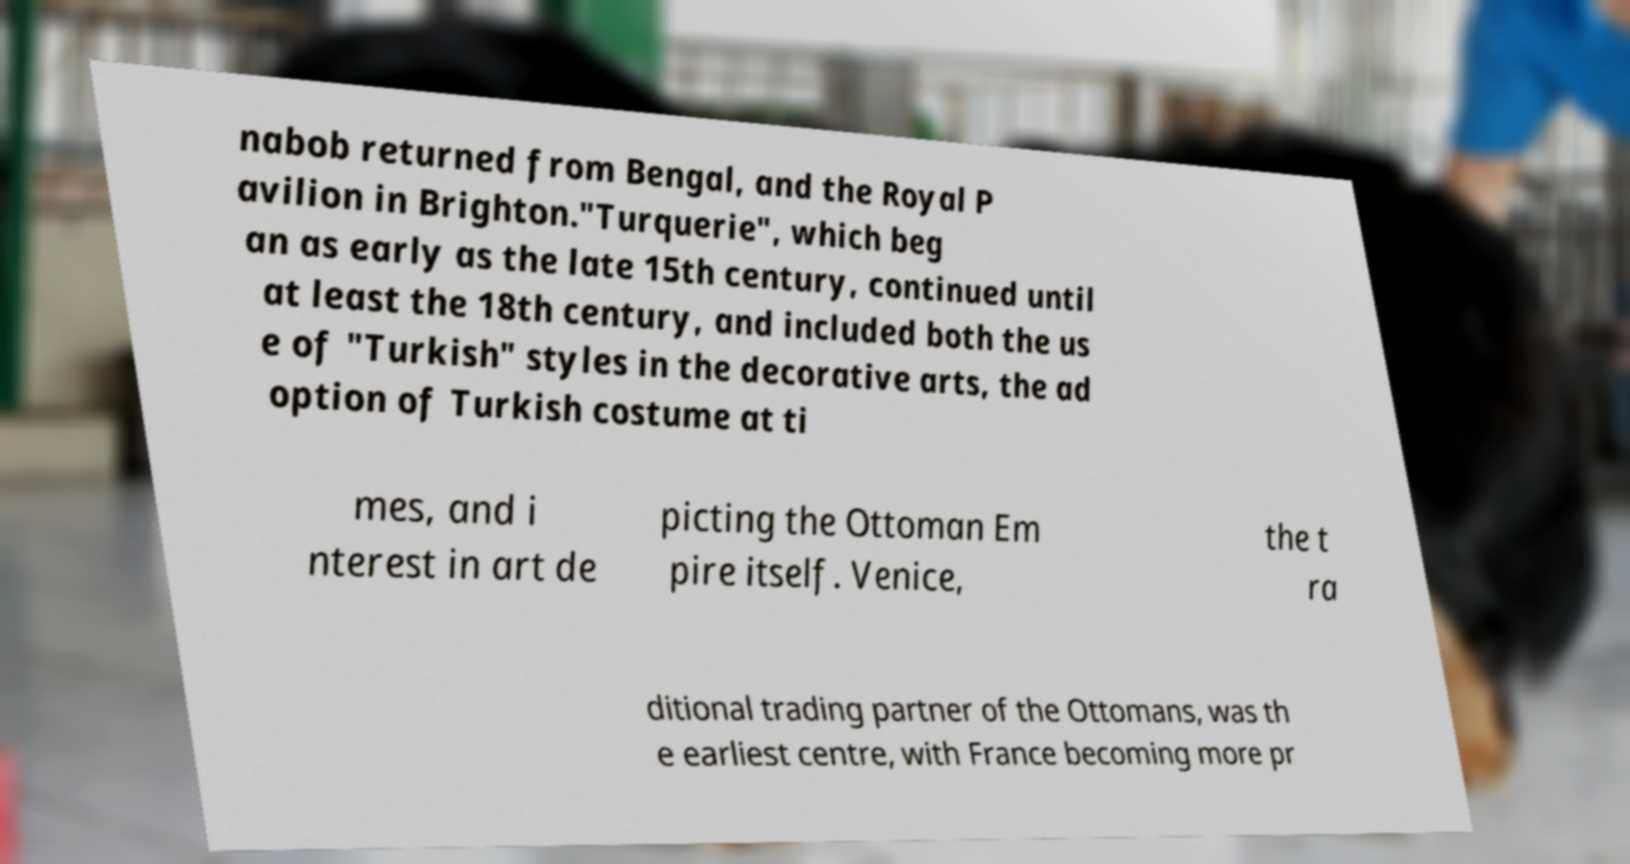Could you assist in decoding the text presented in this image and type it out clearly? nabob returned from Bengal, and the Royal P avilion in Brighton."Turquerie", which beg an as early as the late 15th century, continued until at least the 18th century, and included both the us e of "Turkish" styles in the decorative arts, the ad option of Turkish costume at ti mes, and i nterest in art de picting the Ottoman Em pire itself. Venice, the t ra ditional trading partner of the Ottomans, was th e earliest centre, with France becoming more pr 